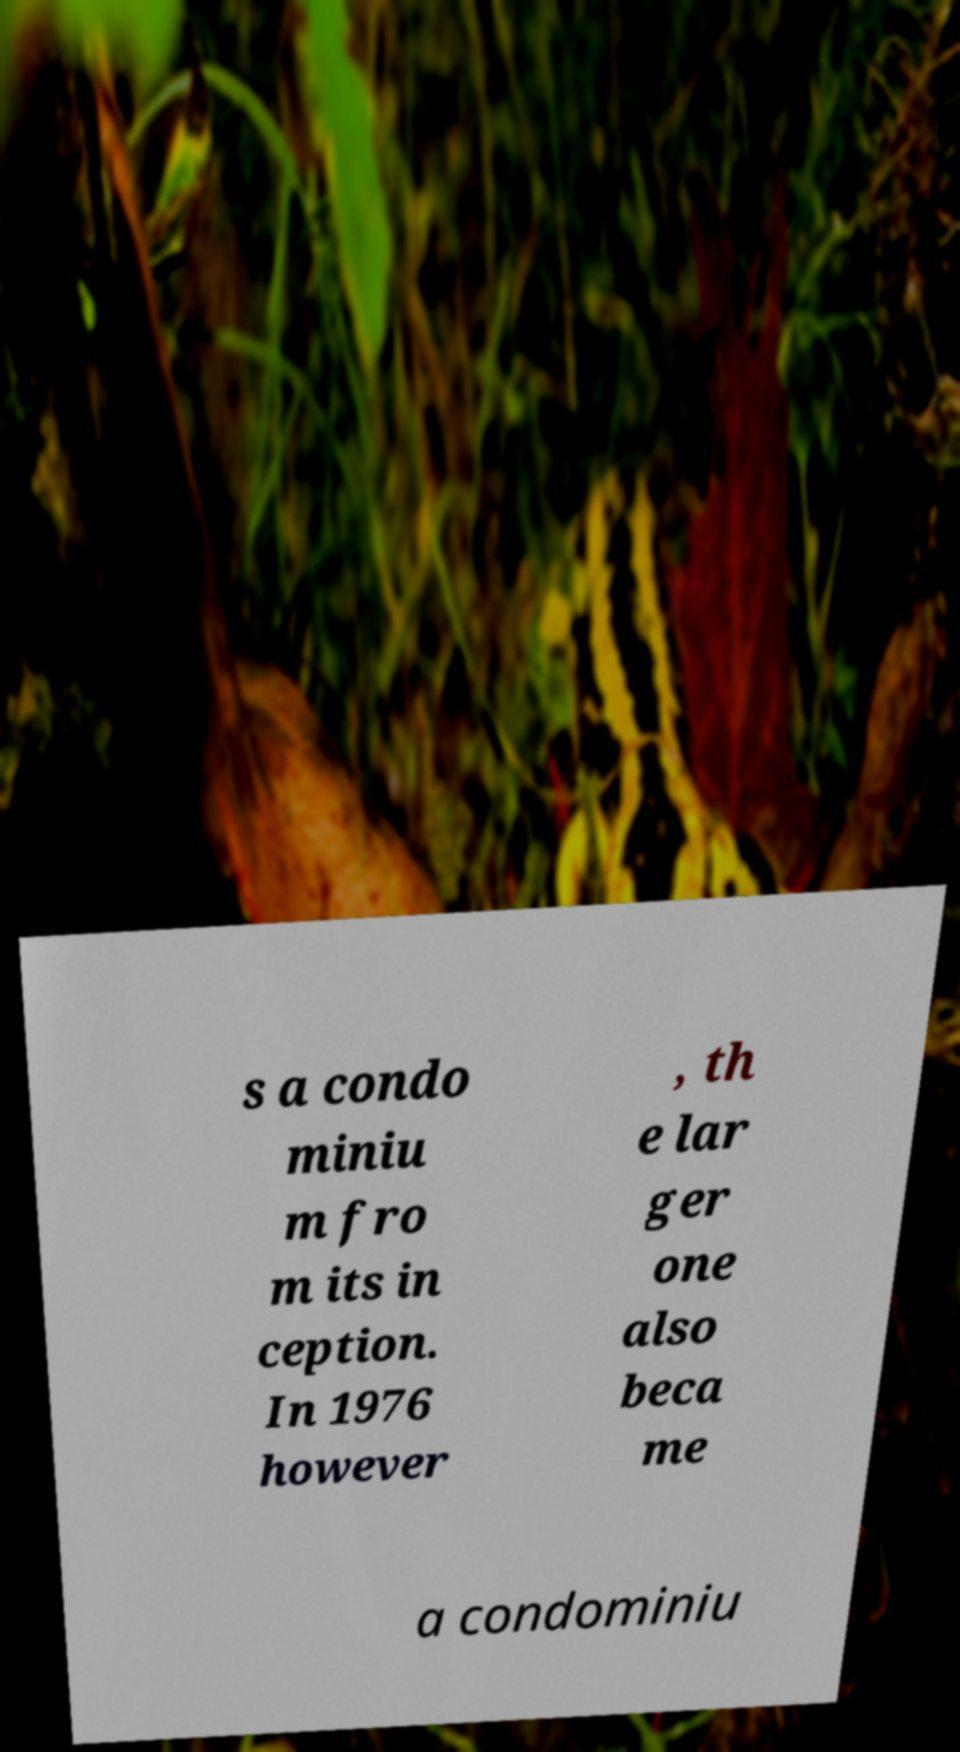For documentation purposes, I need the text within this image transcribed. Could you provide that? s a condo miniu m fro m its in ception. In 1976 however , th e lar ger one also beca me a condominiu 